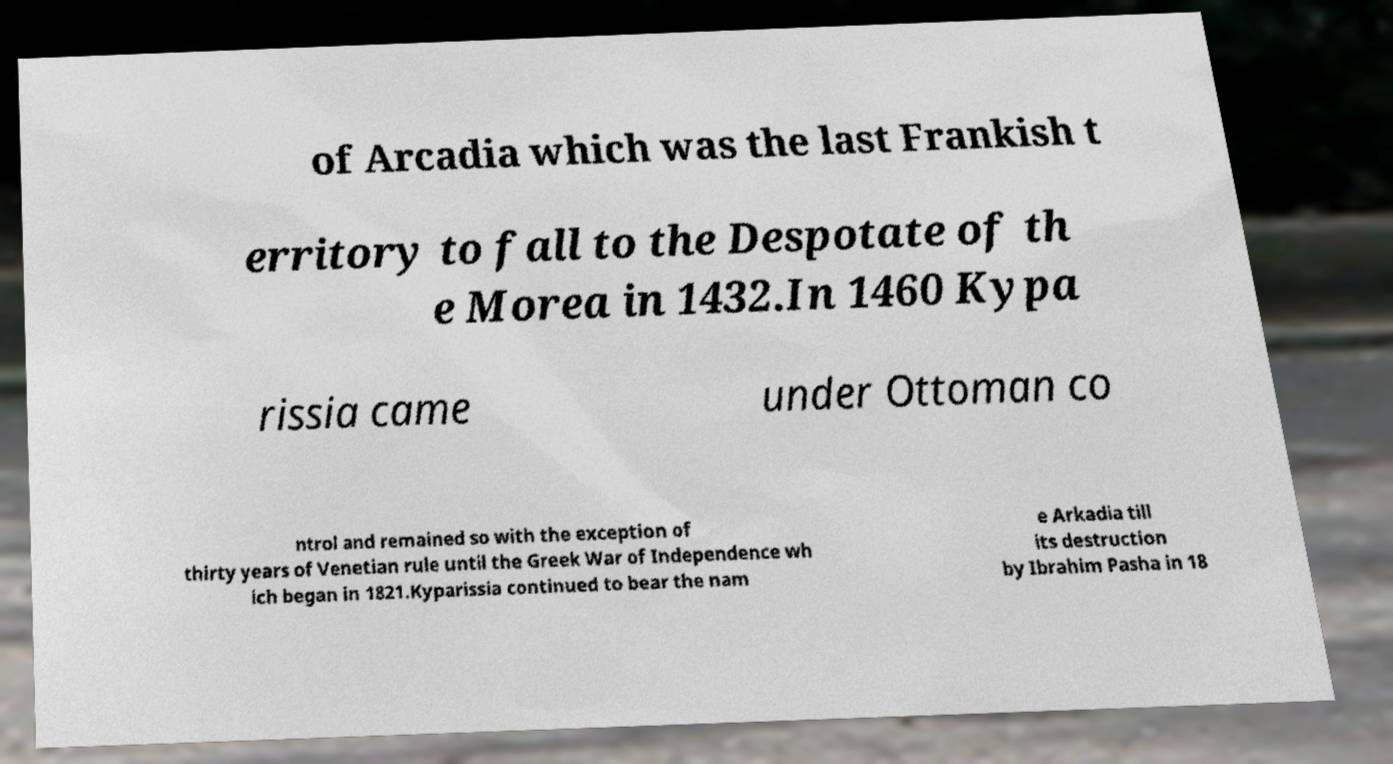Can you accurately transcribe the text from the provided image for me? of Arcadia which was the last Frankish t erritory to fall to the Despotate of th e Morea in 1432.In 1460 Kypa rissia came under Ottoman co ntrol and remained so with the exception of thirty years of Venetian rule until the Greek War of Independence wh ich began in 1821.Kyparissia continued to bear the nam e Arkadia till its destruction by Ibrahim Pasha in 18 